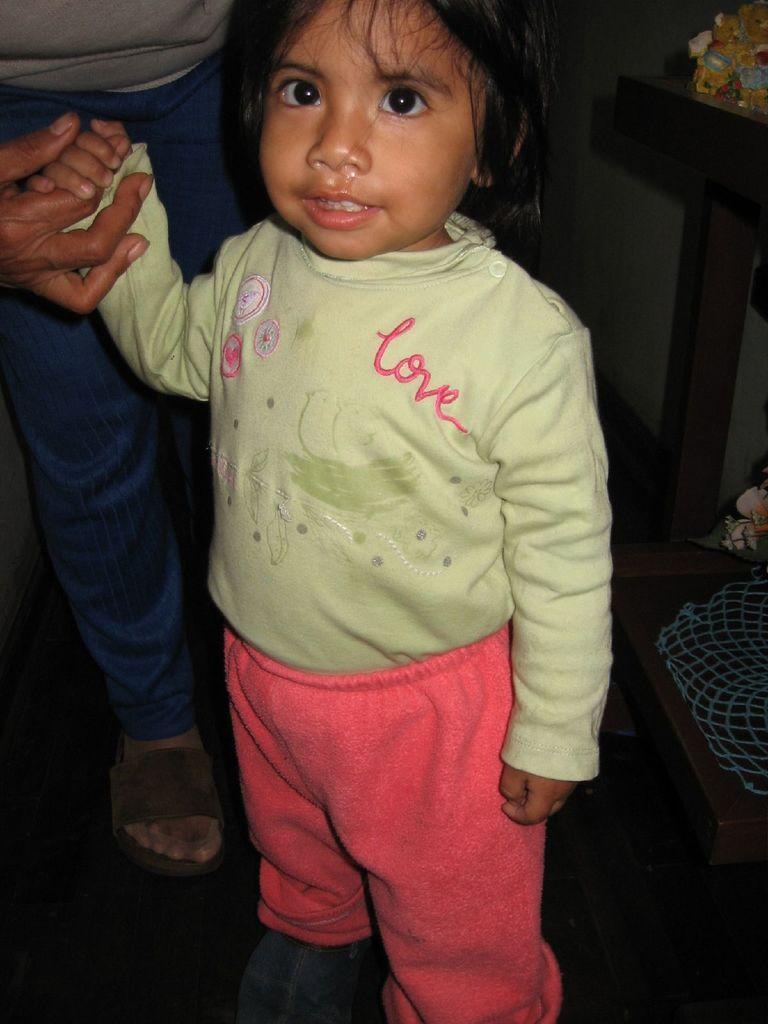Describe this image in one or two sentences. In this image in the front there is a girl standing and there is the person holding a hand of the girl. On the right side there is a table, on the table there is an object. 